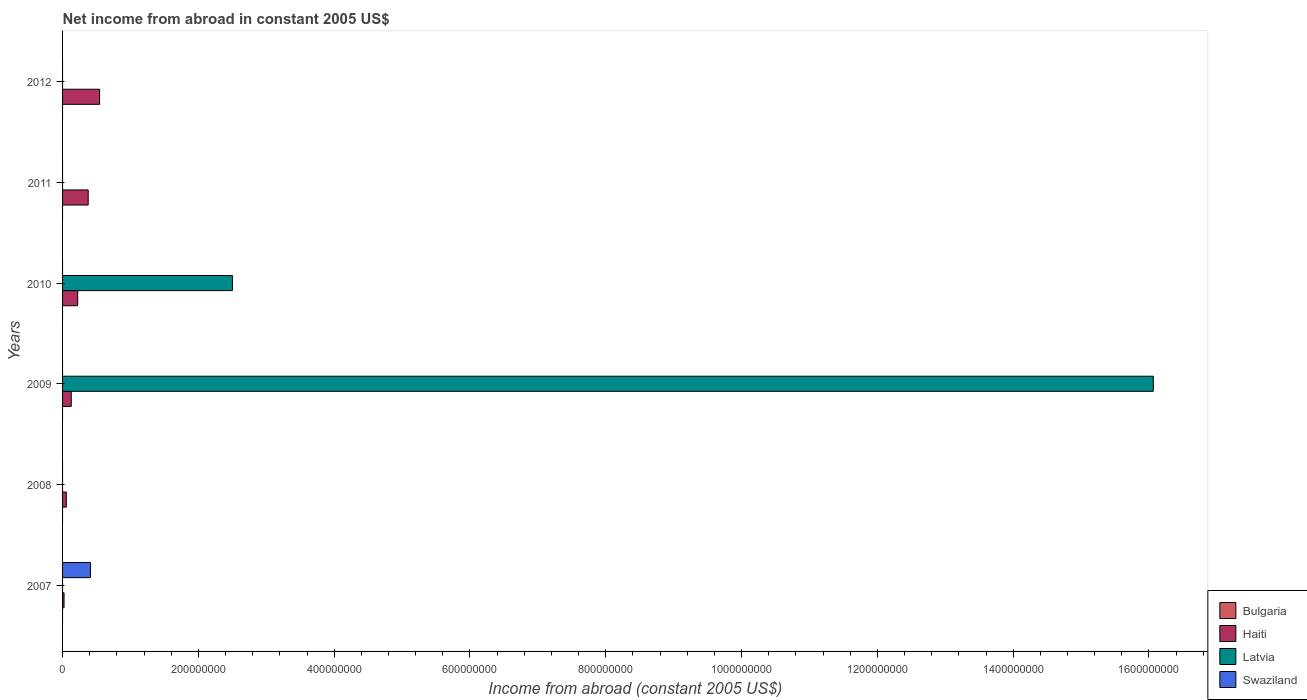How many different coloured bars are there?
Provide a succinct answer. 3. Are the number of bars per tick equal to the number of legend labels?
Ensure brevity in your answer.  No. Are the number of bars on each tick of the Y-axis equal?
Offer a terse response. No. How many bars are there on the 4th tick from the top?
Provide a succinct answer. 2. How many bars are there on the 2nd tick from the bottom?
Provide a short and direct response. 1. What is the label of the 5th group of bars from the top?
Offer a terse response. 2008. What is the net income from abroad in Haiti in 2010?
Provide a short and direct response. 2.23e+07. Across all years, what is the maximum net income from abroad in Swaziland?
Provide a succinct answer. 4.11e+07. Across all years, what is the minimum net income from abroad in Bulgaria?
Provide a succinct answer. 0. In which year was the net income from abroad in Swaziland maximum?
Keep it short and to the point. 2007. What is the total net income from abroad in Latvia in the graph?
Make the answer very short. 1.86e+09. What is the difference between the net income from abroad in Haiti in 2008 and that in 2010?
Provide a short and direct response. -1.67e+07. What is the difference between the net income from abroad in Haiti in 2010 and the net income from abroad in Bulgaria in 2007?
Give a very brief answer. 2.23e+07. What is the average net income from abroad in Latvia per year?
Offer a very short reply. 3.09e+08. In how many years, is the net income from abroad in Haiti greater than 1560000000 US$?
Ensure brevity in your answer.  0. What is the ratio of the net income from abroad in Haiti in 2008 to that in 2009?
Your answer should be very brief. 0.43. What is the difference between the highest and the second highest net income from abroad in Haiti?
Keep it short and to the point. 1.68e+07. What is the difference between the highest and the lowest net income from abroad in Swaziland?
Your response must be concise. 4.11e+07. In how many years, is the net income from abroad in Latvia greater than the average net income from abroad in Latvia taken over all years?
Give a very brief answer. 1. Is the sum of the net income from abroad in Haiti in 2008 and 2009 greater than the maximum net income from abroad in Swaziland across all years?
Give a very brief answer. No. Is it the case that in every year, the sum of the net income from abroad in Bulgaria and net income from abroad in Haiti is greater than the sum of net income from abroad in Swaziland and net income from abroad in Latvia?
Make the answer very short. Yes. Is it the case that in every year, the sum of the net income from abroad in Haiti and net income from abroad in Bulgaria is greater than the net income from abroad in Swaziland?
Ensure brevity in your answer.  No. Are all the bars in the graph horizontal?
Offer a very short reply. Yes. How many years are there in the graph?
Keep it short and to the point. 6. Does the graph contain any zero values?
Provide a short and direct response. Yes. Does the graph contain grids?
Provide a succinct answer. No. How many legend labels are there?
Your answer should be very brief. 4. How are the legend labels stacked?
Make the answer very short. Vertical. What is the title of the graph?
Ensure brevity in your answer.  Net income from abroad in constant 2005 US$. What is the label or title of the X-axis?
Ensure brevity in your answer.  Income from abroad (constant 2005 US$). What is the Income from abroad (constant 2005 US$) of Bulgaria in 2007?
Your answer should be compact. 0. What is the Income from abroad (constant 2005 US$) of Haiti in 2007?
Ensure brevity in your answer.  2.19e+06. What is the Income from abroad (constant 2005 US$) in Swaziland in 2007?
Give a very brief answer. 4.11e+07. What is the Income from abroad (constant 2005 US$) of Haiti in 2008?
Make the answer very short. 5.54e+06. What is the Income from abroad (constant 2005 US$) of Latvia in 2008?
Keep it short and to the point. 0. What is the Income from abroad (constant 2005 US$) in Swaziland in 2008?
Your response must be concise. 0. What is the Income from abroad (constant 2005 US$) of Bulgaria in 2009?
Give a very brief answer. 0. What is the Income from abroad (constant 2005 US$) of Haiti in 2009?
Keep it short and to the point. 1.28e+07. What is the Income from abroad (constant 2005 US$) of Latvia in 2009?
Make the answer very short. 1.61e+09. What is the Income from abroad (constant 2005 US$) of Haiti in 2010?
Provide a short and direct response. 2.23e+07. What is the Income from abroad (constant 2005 US$) of Latvia in 2010?
Provide a succinct answer. 2.50e+08. What is the Income from abroad (constant 2005 US$) of Swaziland in 2010?
Your answer should be very brief. 0. What is the Income from abroad (constant 2005 US$) of Haiti in 2011?
Provide a short and direct response. 3.78e+07. What is the Income from abroad (constant 2005 US$) in Latvia in 2011?
Your answer should be compact. 0. What is the Income from abroad (constant 2005 US$) in Bulgaria in 2012?
Ensure brevity in your answer.  0. What is the Income from abroad (constant 2005 US$) in Haiti in 2012?
Your answer should be compact. 5.45e+07. Across all years, what is the maximum Income from abroad (constant 2005 US$) of Haiti?
Make the answer very short. 5.45e+07. Across all years, what is the maximum Income from abroad (constant 2005 US$) of Latvia?
Keep it short and to the point. 1.61e+09. Across all years, what is the maximum Income from abroad (constant 2005 US$) of Swaziland?
Keep it short and to the point. 4.11e+07. Across all years, what is the minimum Income from abroad (constant 2005 US$) in Haiti?
Give a very brief answer. 2.19e+06. Across all years, what is the minimum Income from abroad (constant 2005 US$) of Latvia?
Provide a short and direct response. 0. What is the total Income from abroad (constant 2005 US$) in Haiti in the graph?
Give a very brief answer. 1.35e+08. What is the total Income from abroad (constant 2005 US$) in Latvia in the graph?
Offer a terse response. 1.86e+09. What is the total Income from abroad (constant 2005 US$) of Swaziland in the graph?
Your answer should be very brief. 4.11e+07. What is the difference between the Income from abroad (constant 2005 US$) in Haiti in 2007 and that in 2008?
Your response must be concise. -3.35e+06. What is the difference between the Income from abroad (constant 2005 US$) of Haiti in 2007 and that in 2009?
Give a very brief answer. -1.06e+07. What is the difference between the Income from abroad (constant 2005 US$) in Haiti in 2007 and that in 2010?
Your answer should be very brief. -2.01e+07. What is the difference between the Income from abroad (constant 2005 US$) of Haiti in 2007 and that in 2011?
Your answer should be compact. -3.56e+07. What is the difference between the Income from abroad (constant 2005 US$) in Haiti in 2007 and that in 2012?
Your answer should be very brief. -5.23e+07. What is the difference between the Income from abroad (constant 2005 US$) of Haiti in 2008 and that in 2009?
Provide a short and direct response. -7.27e+06. What is the difference between the Income from abroad (constant 2005 US$) of Haiti in 2008 and that in 2010?
Make the answer very short. -1.67e+07. What is the difference between the Income from abroad (constant 2005 US$) in Haiti in 2008 and that in 2011?
Keep it short and to the point. -3.22e+07. What is the difference between the Income from abroad (constant 2005 US$) of Haiti in 2008 and that in 2012?
Your response must be concise. -4.90e+07. What is the difference between the Income from abroad (constant 2005 US$) of Haiti in 2009 and that in 2010?
Ensure brevity in your answer.  -9.47e+06. What is the difference between the Income from abroad (constant 2005 US$) of Latvia in 2009 and that in 2010?
Make the answer very short. 1.36e+09. What is the difference between the Income from abroad (constant 2005 US$) of Haiti in 2009 and that in 2011?
Give a very brief answer. -2.50e+07. What is the difference between the Income from abroad (constant 2005 US$) of Haiti in 2009 and that in 2012?
Your answer should be compact. -4.17e+07. What is the difference between the Income from abroad (constant 2005 US$) in Haiti in 2010 and that in 2011?
Offer a very short reply. -1.55e+07. What is the difference between the Income from abroad (constant 2005 US$) in Haiti in 2010 and that in 2012?
Your answer should be compact. -3.23e+07. What is the difference between the Income from abroad (constant 2005 US$) of Haiti in 2011 and that in 2012?
Ensure brevity in your answer.  -1.68e+07. What is the difference between the Income from abroad (constant 2005 US$) of Haiti in 2007 and the Income from abroad (constant 2005 US$) of Latvia in 2009?
Provide a succinct answer. -1.60e+09. What is the difference between the Income from abroad (constant 2005 US$) of Haiti in 2007 and the Income from abroad (constant 2005 US$) of Latvia in 2010?
Keep it short and to the point. -2.48e+08. What is the difference between the Income from abroad (constant 2005 US$) of Haiti in 2008 and the Income from abroad (constant 2005 US$) of Latvia in 2009?
Provide a short and direct response. -1.60e+09. What is the difference between the Income from abroad (constant 2005 US$) of Haiti in 2008 and the Income from abroad (constant 2005 US$) of Latvia in 2010?
Your answer should be very brief. -2.45e+08. What is the difference between the Income from abroad (constant 2005 US$) of Haiti in 2009 and the Income from abroad (constant 2005 US$) of Latvia in 2010?
Offer a terse response. -2.37e+08. What is the average Income from abroad (constant 2005 US$) in Bulgaria per year?
Keep it short and to the point. 0. What is the average Income from abroad (constant 2005 US$) in Haiti per year?
Offer a very short reply. 2.25e+07. What is the average Income from abroad (constant 2005 US$) in Latvia per year?
Your answer should be compact. 3.09e+08. What is the average Income from abroad (constant 2005 US$) of Swaziland per year?
Keep it short and to the point. 6.85e+06. In the year 2007, what is the difference between the Income from abroad (constant 2005 US$) of Haiti and Income from abroad (constant 2005 US$) of Swaziland?
Make the answer very short. -3.89e+07. In the year 2009, what is the difference between the Income from abroad (constant 2005 US$) of Haiti and Income from abroad (constant 2005 US$) of Latvia?
Offer a terse response. -1.59e+09. In the year 2010, what is the difference between the Income from abroad (constant 2005 US$) of Haiti and Income from abroad (constant 2005 US$) of Latvia?
Make the answer very short. -2.28e+08. What is the ratio of the Income from abroad (constant 2005 US$) in Haiti in 2007 to that in 2008?
Ensure brevity in your answer.  0.4. What is the ratio of the Income from abroad (constant 2005 US$) of Haiti in 2007 to that in 2009?
Your response must be concise. 0.17. What is the ratio of the Income from abroad (constant 2005 US$) of Haiti in 2007 to that in 2010?
Your answer should be compact. 0.1. What is the ratio of the Income from abroad (constant 2005 US$) in Haiti in 2007 to that in 2011?
Make the answer very short. 0.06. What is the ratio of the Income from abroad (constant 2005 US$) in Haiti in 2007 to that in 2012?
Keep it short and to the point. 0.04. What is the ratio of the Income from abroad (constant 2005 US$) of Haiti in 2008 to that in 2009?
Ensure brevity in your answer.  0.43. What is the ratio of the Income from abroad (constant 2005 US$) of Haiti in 2008 to that in 2010?
Your answer should be very brief. 0.25. What is the ratio of the Income from abroad (constant 2005 US$) of Haiti in 2008 to that in 2011?
Provide a succinct answer. 0.15. What is the ratio of the Income from abroad (constant 2005 US$) in Haiti in 2008 to that in 2012?
Keep it short and to the point. 0.1. What is the ratio of the Income from abroad (constant 2005 US$) in Haiti in 2009 to that in 2010?
Give a very brief answer. 0.57. What is the ratio of the Income from abroad (constant 2005 US$) in Latvia in 2009 to that in 2010?
Ensure brevity in your answer.  6.42. What is the ratio of the Income from abroad (constant 2005 US$) of Haiti in 2009 to that in 2011?
Your response must be concise. 0.34. What is the ratio of the Income from abroad (constant 2005 US$) in Haiti in 2009 to that in 2012?
Provide a succinct answer. 0.23. What is the ratio of the Income from abroad (constant 2005 US$) in Haiti in 2010 to that in 2011?
Your response must be concise. 0.59. What is the ratio of the Income from abroad (constant 2005 US$) of Haiti in 2010 to that in 2012?
Your answer should be very brief. 0.41. What is the ratio of the Income from abroad (constant 2005 US$) of Haiti in 2011 to that in 2012?
Your answer should be very brief. 0.69. What is the difference between the highest and the second highest Income from abroad (constant 2005 US$) of Haiti?
Your answer should be compact. 1.68e+07. What is the difference between the highest and the lowest Income from abroad (constant 2005 US$) of Haiti?
Make the answer very short. 5.23e+07. What is the difference between the highest and the lowest Income from abroad (constant 2005 US$) in Latvia?
Provide a short and direct response. 1.61e+09. What is the difference between the highest and the lowest Income from abroad (constant 2005 US$) of Swaziland?
Offer a very short reply. 4.11e+07. 